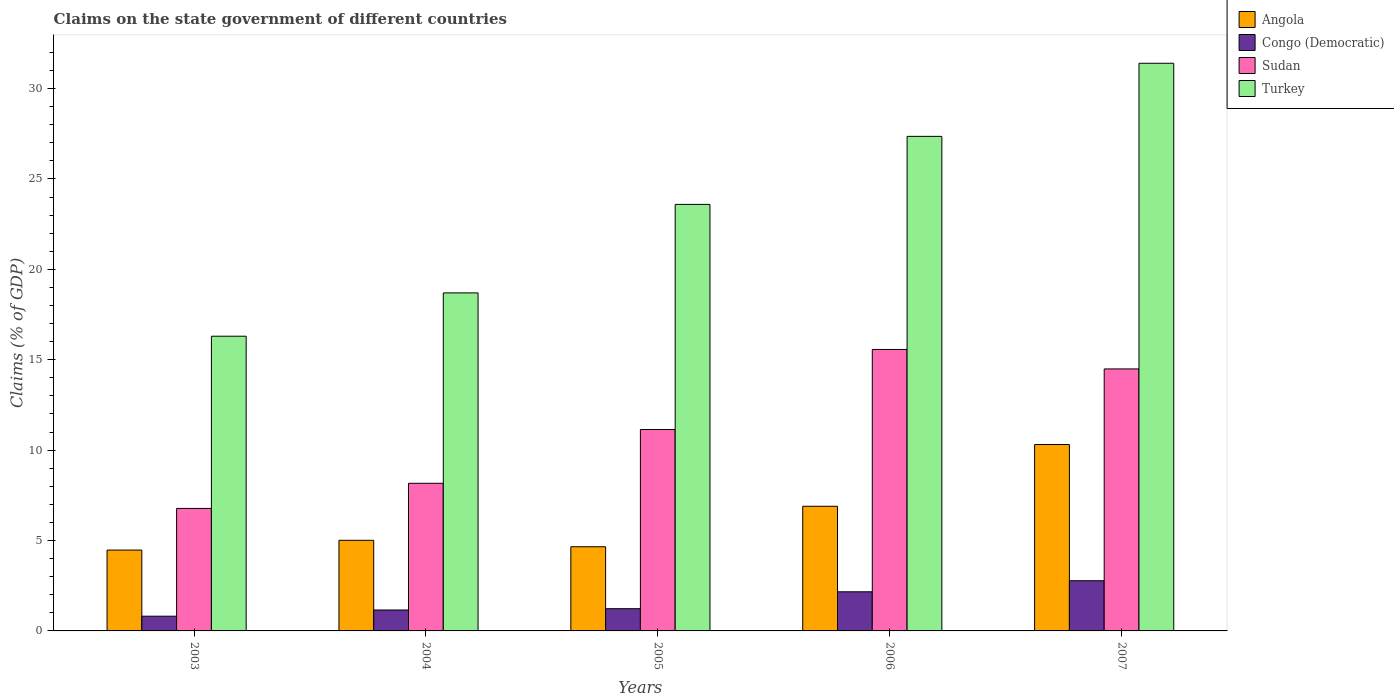How many different coloured bars are there?
Offer a very short reply. 4. How many groups of bars are there?
Your response must be concise. 5. Are the number of bars per tick equal to the number of legend labels?
Ensure brevity in your answer.  Yes. How many bars are there on the 3rd tick from the right?
Offer a very short reply. 4. What is the percentage of GDP claimed on the state government in Sudan in 2005?
Give a very brief answer. 11.14. Across all years, what is the maximum percentage of GDP claimed on the state government in Congo (Democratic)?
Your answer should be very brief. 2.78. Across all years, what is the minimum percentage of GDP claimed on the state government in Sudan?
Keep it short and to the point. 6.77. What is the total percentage of GDP claimed on the state government in Angola in the graph?
Your response must be concise. 31.34. What is the difference between the percentage of GDP claimed on the state government in Turkey in 2005 and that in 2006?
Keep it short and to the point. -3.76. What is the difference between the percentage of GDP claimed on the state government in Turkey in 2007 and the percentage of GDP claimed on the state government in Congo (Democratic) in 2004?
Your answer should be very brief. 30.24. What is the average percentage of GDP claimed on the state government in Turkey per year?
Your answer should be very brief. 23.47. In the year 2006, what is the difference between the percentage of GDP claimed on the state government in Turkey and percentage of GDP claimed on the state government in Congo (Democratic)?
Your answer should be compact. 25.19. In how many years, is the percentage of GDP claimed on the state government in Turkey greater than 24 %?
Ensure brevity in your answer.  2. What is the ratio of the percentage of GDP claimed on the state government in Sudan in 2004 to that in 2007?
Provide a short and direct response. 0.56. Is the difference between the percentage of GDP claimed on the state government in Turkey in 2004 and 2007 greater than the difference between the percentage of GDP claimed on the state government in Congo (Democratic) in 2004 and 2007?
Offer a very short reply. No. What is the difference between the highest and the second highest percentage of GDP claimed on the state government in Sudan?
Provide a short and direct response. 1.08. What is the difference between the highest and the lowest percentage of GDP claimed on the state government in Turkey?
Your answer should be very brief. 15.1. What does the 4th bar from the left in 2007 represents?
Your answer should be compact. Turkey. What does the 4th bar from the right in 2004 represents?
Keep it short and to the point. Angola. Is it the case that in every year, the sum of the percentage of GDP claimed on the state government in Congo (Democratic) and percentage of GDP claimed on the state government in Angola is greater than the percentage of GDP claimed on the state government in Turkey?
Give a very brief answer. No. Are all the bars in the graph horizontal?
Offer a very short reply. No. How many years are there in the graph?
Provide a succinct answer. 5. What is the difference between two consecutive major ticks on the Y-axis?
Provide a succinct answer. 5. Does the graph contain any zero values?
Ensure brevity in your answer.  No. Where does the legend appear in the graph?
Your response must be concise. Top right. How many legend labels are there?
Make the answer very short. 4. How are the legend labels stacked?
Provide a succinct answer. Vertical. What is the title of the graph?
Your answer should be very brief. Claims on the state government of different countries. Does "Swaziland" appear as one of the legend labels in the graph?
Make the answer very short. No. What is the label or title of the X-axis?
Your answer should be very brief. Years. What is the label or title of the Y-axis?
Offer a terse response. Claims (% of GDP). What is the Claims (% of GDP) in Angola in 2003?
Your answer should be very brief. 4.47. What is the Claims (% of GDP) of Congo (Democratic) in 2003?
Offer a very short reply. 0.81. What is the Claims (% of GDP) of Sudan in 2003?
Make the answer very short. 6.77. What is the Claims (% of GDP) in Turkey in 2003?
Offer a very short reply. 16.3. What is the Claims (% of GDP) in Angola in 2004?
Your answer should be compact. 5.01. What is the Claims (% of GDP) in Congo (Democratic) in 2004?
Ensure brevity in your answer.  1.16. What is the Claims (% of GDP) of Sudan in 2004?
Your answer should be very brief. 8.17. What is the Claims (% of GDP) in Turkey in 2004?
Your response must be concise. 18.7. What is the Claims (% of GDP) in Angola in 2005?
Your response must be concise. 4.66. What is the Claims (% of GDP) of Congo (Democratic) in 2005?
Ensure brevity in your answer.  1.23. What is the Claims (% of GDP) of Sudan in 2005?
Ensure brevity in your answer.  11.14. What is the Claims (% of GDP) in Turkey in 2005?
Offer a very short reply. 23.59. What is the Claims (% of GDP) in Angola in 2006?
Offer a very short reply. 6.89. What is the Claims (% of GDP) of Congo (Democratic) in 2006?
Offer a terse response. 2.16. What is the Claims (% of GDP) of Sudan in 2006?
Provide a short and direct response. 15.57. What is the Claims (% of GDP) of Turkey in 2006?
Make the answer very short. 27.35. What is the Claims (% of GDP) of Angola in 2007?
Your answer should be very brief. 10.31. What is the Claims (% of GDP) in Congo (Democratic) in 2007?
Offer a terse response. 2.78. What is the Claims (% of GDP) of Sudan in 2007?
Ensure brevity in your answer.  14.49. What is the Claims (% of GDP) in Turkey in 2007?
Keep it short and to the point. 31.4. Across all years, what is the maximum Claims (% of GDP) in Angola?
Provide a short and direct response. 10.31. Across all years, what is the maximum Claims (% of GDP) in Congo (Democratic)?
Provide a succinct answer. 2.78. Across all years, what is the maximum Claims (% of GDP) of Sudan?
Offer a terse response. 15.57. Across all years, what is the maximum Claims (% of GDP) of Turkey?
Offer a terse response. 31.4. Across all years, what is the minimum Claims (% of GDP) of Angola?
Ensure brevity in your answer.  4.47. Across all years, what is the minimum Claims (% of GDP) of Congo (Democratic)?
Ensure brevity in your answer.  0.81. Across all years, what is the minimum Claims (% of GDP) of Sudan?
Your answer should be compact. 6.77. Across all years, what is the minimum Claims (% of GDP) of Turkey?
Provide a succinct answer. 16.3. What is the total Claims (% of GDP) of Angola in the graph?
Your answer should be compact. 31.34. What is the total Claims (% of GDP) of Congo (Democratic) in the graph?
Provide a succinct answer. 8.14. What is the total Claims (% of GDP) of Sudan in the graph?
Offer a terse response. 56.14. What is the total Claims (% of GDP) of Turkey in the graph?
Keep it short and to the point. 117.34. What is the difference between the Claims (% of GDP) of Angola in 2003 and that in 2004?
Provide a short and direct response. -0.54. What is the difference between the Claims (% of GDP) in Congo (Democratic) in 2003 and that in 2004?
Your answer should be very brief. -0.34. What is the difference between the Claims (% of GDP) in Sudan in 2003 and that in 2004?
Make the answer very short. -1.39. What is the difference between the Claims (% of GDP) in Turkey in 2003 and that in 2004?
Make the answer very short. -2.4. What is the difference between the Claims (% of GDP) of Angola in 2003 and that in 2005?
Give a very brief answer. -0.18. What is the difference between the Claims (% of GDP) of Congo (Democratic) in 2003 and that in 2005?
Your answer should be compact. -0.41. What is the difference between the Claims (% of GDP) of Sudan in 2003 and that in 2005?
Offer a terse response. -4.36. What is the difference between the Claims (% of GDP) of Turkey in 2003 and that in 2005?
Give a very brief answer. -7.29. What is the difference between the Claims (% of GDP) in Angola in 2003 and that in 2006?
Provide a short and direct response. -2.42. What is the difference between the Claims (% of GDP) in Congo (Democratic) in 2003 and that in 2006?
Make the answer very short. -1.35. What is the difference between the Claims (% of GDP) of Sudan in 2003 and that in 2006?
Keep it short and to the point. -8.79. What is the difference between the Claims (% of GDP) of Turkey in 2003 and that in 2006?
Your answer should be compact. -11.05. What is the difference between the Claims (% of GDP) of Angola in 2003 and that in 2007?
Provide a succinct answer. -5.84. What is the difference between the Claims (% of GDP) in Congo (Democratic) in 2003 and that in 2007?
Provide a succinct answer. -1.96. What is the difference between the Claims (% of GDP) of Sudan in 2003 and that in 2007?
Offer a terse response. -7.72. What is the difference between the Claims (% of GDP) in Turkey in 2003 and that in 2007?
Ensure brevity in your answer.  -15.1. What is the difference between the Claims (% of GDP) of Angola in 2004 and that in 2005?
Offer a very short reply. 0.36. What is the difference between the Claims (% of GDP) of Congo (Democratic) in 2004 and that in 2005?
Your response must be concise. -0.07. What is the difference between the Claims (% of GDP) in Sudan in 2004 and that in 2005?
Give a very brief answer. -2.97. What is the difference between the Claims (% of GDP) of Turkey in 2004 and that in 2005?
Offer a terse response. -4.89. What is the difference between the Claims (% of GDP) in Angola in 2004 and that in 2006?
Give a very brief answer. -1.88. What is the difference between the Claims (% of GDP) of Congo (Democratic) in 2004 and that in 2006?
Your answer should be compact. -1.01. What is the difference between the Claims (% of GDP) in Sudan in 2004 and that in 2006?
Provide a succinct answer. -7.4. What is the difference between the Claims (% of GDP) in Turkey in 2004 and that in 2006?
Make the answer very short. -8.66. What is the difference between the Claims (% of GDP) of Angola in 2004 and that in 2007?
Make the answer very short. -5.3. What is the difference between the Claims (% of GDP) in Congo (Democratic) in 2004 and that in 2007?
Your answer should be very brief. -1.62. What is the difference between the Claims (% of GDP) of Sudan in 2004 and that in 2007?
Your response must be concise. -6.33. What is the difference between the Claims (% of GDP) in Turkey in 2004 and that in 2007?
Your answer should be very brief. -12.7. What is the difference between the Claims (% of GDP) in Angola in 2005 and that in 2006?
Provide a short and direct response. -2.24. What is the difference between the Claims (% of GDP) of Congo (Democratic) in 2005 and that in 2006?
Give a very brief answer. -0.94. What is the difference between the Claims (% of GDP) of Sudan in 2005 and that in 2006?
Your response must be concise. -4.43. What is the difference between the Claims (% of GDP) of Turkey in 2005 and that in 2006?
Offer a very short reply. -3.76. What is the difference between the Claims (% of GDP) of Angola in 2005 and that in 2007?
Keep it short and to the point. -5.65. What is the difference between the Claims (% of GDP) in Congo (Democratic) in 2005 and that in 2007?
Make the answer very short. -1.55. What is the difference between the Claims (% of GDP) in Sudan in 2005 and that in 2007?
Ensure brevity in your answer.  -3.35. What is the difference between the Claims (% of GDP) of Turkey in 2005 and that in 2007?
Make the answer very short. -7.81. What is the difference between the Claims (% of GDP) of Angola in 2006 and that in 2007?
Give a very brief answer. -3.42. What is the difference between the Claims (% of GDP) of Congo (Democratic) in 2006 and that in 2007?
Offer a very short reply. -0.61. What is the difference between the Claims (% of GDP) of Sudan in 2006 and that in 2007?
Your answer should be compact. 1.08. What is the difference between the Claims (% of GDP) in Turkey in 2006 and that in 2007?
Keep it short and to the point. -4.04. What is the difference between the Claims (% of GDP) in Angola in 2003 and the Claims (% of GDP) in Congo (Democratic) in 2004?
Make the answer very short. 3.31. What is the difference between the Claims (% of GDP) in Angola in 2003 and the Claims (% of GDP) in Sudan in 2004?
Ensure brevity in your answer.  -3.69. What is the difference between the Claims (% of GDP) of Angola in 2003 and the Claims (% of GDP) of Turkey in 2004?
Make the answer very short. -14.22. What is the difference between the Claims (% of GDP) in Congo (Democratic) in 2003 and the Claims (% of GDP) in Sudan in 2004?
Provide a succinct answer. -7.35. What is the difference between the Claims (% of GDP) in Congo (Democratic) in 2003 and the Claims (% of GDP) in Turkey in 2004?
Your answer should be very brief. -17.88. What is the difference between the Claims (% of GDP) in Sudan in 2003 and the Claims (% of GDP) in Turkey in 2004?
Offer a terse response. -11.92. What is the difference between the Claims (% of GDP) of Angola in 2003 and the Claims (% of GDP) of Congo (Democratic) in 2005?
Your response must be concise. 3.24. What is the difference between the Claims (% of GDP) of Angola in 2003 and the Claims (% of GDP) of Sudan in 2005?
Provide a succinct answer. -6.67. What is the difference between the Claims (% of GDP) of Angola in 2003 and the Claims (% of GDP) of Turkey in 2005?
Give a very brief answer. -19.12. What is the difference between the Claims (% of GDP) in Congo (Democratic) in 2003 and the Claims (% of GDP) in Sudan in 2005?
Give a very brief answer. -10.32. What is the difference between the Claims (% of GDP) of Congo (Democratic) in 2003 and the Claims (% of GDP) of Turkey in 2005?
Your answer should be compact. -22.78. What is the difference between the Claims (% of GDP) of Sudan in 2003 and the Claims (% of GDP) of Turkey in 2005?
Ensure brevity in your answer.  -16.82. What is the difference between the Claims (% of GDP) in Angola in 2003 and the Claims (% of GDP) in Congo (Democratic) in 2006?
Make the answer very short. 2.31. What is the difference between the Claims (% of GDP) in Angola in 2003 and the Claims (% of GDP) in Sudan in 2006?
Your answer should be very brief. -11.1. What is the difference between the Claims (% of GDP) in Angola in 2003 and the Claims (% of GDP) in Turkey in 2006?
Provide a succinct answer. -22.88. What is the difference between the Claims (% of GDP) in Congo (Democratic) in 2003 and the Claims (% of GDP) in Sudan in 2006?
Provide a short and direct response. -14.75. What is the difference between the Claims (% of GDP) of Congo (Democratic) in 2003 and the Claims (% of GDP) of Turkey in 2006?
Your answer should be very brief. -26.54. What is the difference between the Claims (% of GDP) in Sudan in 2003 and the Claims (% of GDP) in Turkey in 2006?
Your response must be concise. -20.58. What is the difference between the Claims (% of GDP) in Angola in 2003 and the Claims (% of GDP) in Congo (Democratic) in 2007?
Provide a succinct answer. 1.7. What is the difference between the Claims (% of GDP) in Angola in 2003 and the Claims (% of GDP) in Sudan in 2007?
Keep it short and to the point. -10.02. What is the difference between the Claims (% of GDP) in Angola in 2003 and the Claims (% of GDP) in Turkey in 2007?
Provide a short and direct response. -26.93. What is the difference between the Claims (% of GDP) in Congo (Democratic) in 2003 and the Claims (% of GDP) in Sudan in 2007?
Your response must be concise. -13.68. What is the difference between the Claims (% of GDP) of Congo (Democratic) in 2003 and the Claims (% of GDP) of Turkey in 2007?
Offer a terse response. -30.58. What is the difference between the Claims (% of GDP) in Sudan in 2003 and the Claims (% of GDP) in Turkey in 2007?
Give a very brief answer. -24.62. What is the difference between the Claims (% of GDP) in Angola in 2004 and the Claims (% of GDP) in Congo (Democratic) in 2005?
Make the answer very short. 3.78. What is the difference between the Claims (% of GDP) of Angola in 2004 and the Claims (% of GDP) of Sudan in 2005?
Give a very brief answer. -6.13. What is the difference between the Claims (% of GDP) in Angola in 2004 and the Claims (% of GDP) in Turkey in 2005?
Offer a very short reply. -18.58. What is the difference between the Claims (% of GDP) in Congo (Democratic) in 2004 and the Claims (% of GDP) in Sudan in 2005?
Keep it short and to the point. -9.98. What is the difference between the Claims (% of GDP) of Congo (Democratic) in 2004 and the Claims (% of GDP) of Turkey in 2005?
Offer a terse response. -22.43. What is the difference between the Claims (% of GDP) of Sudan in 2004 and the Claims (% of GDP) of Turkey in 2005?
Offer a very short reply. -15.43. What is the difference between the Claims (% of GDP) of Angola in 2004 and the Claims (% of GDP) of Congo (Democratic) in 2006?
Ensure brevity in your answer.  2.85. What is the difference between the Claims (% of GDP) of Angola in 2004 and the Claims (% of GDP) of Sudan in 2006?
Give a very brief answer. -10.56. What is the difference between the Claims (% of GDP) of Angola in 2004 and the Claims (% of GDP) of Turkey in 2006?
Provide a succinct answer. -22.34. What is the difference between the Claims (% of GDP) in Congo (Democratic) in 2004 and the Claims (% of GDP) in Sudan in 2006?
Give a very brief answer. -14.41. What is the difference between the Claims (% of GDP) of Congo (Democratic) in 2004 and the Claims (% of GDP) of Turkey in 2006?
Make the answer very short. -26.2. What is the difference between the Claims (% of GDP) in Sudan in 2004 and the Claims (% of GDP) in Turkey in 2006?
Your answer should be very brief. -19.19. What is the difference between the Claims (% of GDP) of Angola in 2004 and the Claims (% of GDP) of Congo (Democratic) in 2007?
Offer a terse response. 2.24. What is the difference between the Claims (% of GDP) of Angola in 2004 and the Claims (% of GDP) of Sudan in 2007?
Give a very brief answer. -9.48. What is the difference between the Claims (% of GDP) in Angola in 2004 and the Claims (% of GDP) in Turkey in 2007?
Make the answer very short. -26.39. What is the difference between the Claims (% of GDP) of Congo (Democratic) in 2004 and the Claims (% of GDP) of Sudan in 2007?
Provide a short and direct response. -13.33. What is the difference between the Claims (% of GDP) of Congo (Democratic) in 2004 and the Claims (% of GDP) of Turkey in 2007?
Provide a short and direct response. -30.24. What is the difference between the Claims (% of GDP) in Sudan in 2004 and the Claims (% of GDP) in Turkey in 2007?
Your response must be concise. -23.23. What is the difference between the Claims (% of GDP) in Angola in 2005 and the Claims (% of GDP) in Congo (Democratic) in 2006?
Your answer should be compact. 2.49. What is the difference between the Claims (% of GDP) of Angola in 2005 and the Claims (% of GDP) of Sudan in 2006?
Your answer should be very brief. -10.91. What is the difference between the Claims (% of GDP) in Angola in 2005 and the Claims (% of GDP) in Turkey in 2006?
Give a very brief answer. -22.7. What is the difference between the Claims (% of GDP) in Congo (Democratic) in 2005 and the Claims (% of GDP) in Sudan in 2006?
Your answer should be compact. -14.34. What is the difference between the Claims (% of GDP) of Congo (Democratic) in 2005 and the Claims (% of GDP) of Turkey in 2006?
Your response must be concise. -26.12. What is the difference between the Claims (% of GDP) of Sudan in 2005 and the Claims (% of GDP) of Turkey in 2006?
Provide a short and direct response. -16.21. What is the difference between the Claims (% of GDP) of Angola in 2005 and the Claims (% of GDP) of Congo (Democratic) in 2007?
Offer a very short reply. 1.88. What is the difference between the Claims (% of GDP) of Angola in 2005 and the Claims (% of GDP) of Sudan in 2007?
Keep it short and to the point. -9.84. What is the difference between the Claims (% of GDP) of Angola in 2005 and the Claims (% of GDP) of Turkey in 2007?
Your response must be concise. -26.74. What is the difference between the Claims (% of GDP) in Congo (Democratic) in 2005 and the Claims (% of GDP) in Sudan in 2007?
Make the answer very short. -13.26. What is the difference between the Claims (% of GDP) in Congo (Democratic) in 2005 and the Claims (% of GDP) in Turkey in 2007?
Provide a succinct answer. -30.17. What is the difference between the Claims (% of GDP) of Sudan in 2005 and the Claims (% of GDP) of Turkey in 2007?
Offer a very short reply. -20.26. What is the difference between the Claims (% of GDP) of Angola in 2006 and the Claims (% of GDP) of Congo (Democratic) in 2007?
Ensure brevity in your answer.  4.12. What is the difference between the Claims (% of GDP) in Angola in 2006 and the Claims (% of GDP) in Sudan in 2007?
Offer a terse response. -7.6. What is the difference between the Claims (% of GDP) in Angola in 2006 and the Claims (% of GDP) in Turkey in 2007?
Your response must be concise. -24.5. What is the difference between the Claims (% of GDP) in Congo (Democratic) in 2006 and the Claims (% of GDP) in Sudan in 2007?
Offer a very short reply. -12.33. What is the difference between the Claims (% of GDP) of Congo (Democratic) in 2006 and the Claims (% of GDP) of Turkey in 2007?
Offer a terse response. -29.23. What is the difference between the Claims (% of GDP) of Sudan in 2006 and the Claims (% of GDP) of Turkey in 2007?
Keep it short and to the point. -15.83. What is the average Claims (% of GDP) of Angola per year?
Your answer should be compact. 6.27. What is the average Claims (% of GDP) in Congo (Democratic) per year?
Give a very brief answer. 1.63. What is the average Claims (% of GDP) in Sudan per year?
Offer a terse response. 11.23. What is the average Claims (% of GDP) of Turkey per year?
Make the answer very short. 23.47. In the year 2003, what is the difference between the Claims (% of GDP) in Angola and Claims (% of GDP) in Congo (Democratic)?
Offer a terse response. 3.66. In the year 2003, what is the difference between the Claims (% of GDP) of Angola and Claims (% of GDP) of Sudan?
Your response must be concise. -2.3. In the year 2003, what is the difference between the Claims (% of GDP) in Angola and Claims (% of GDP) in Turkey?
Your answer should be very brief. -11.83. In the year 2003, what is the difference between the Claims (% of GDP) in Congo (Democratic) and Claims (% of GDP) in Sudan?
Give a very brief answer. -5.96. In the year 2003, what is the difference between the Claims (% of GDP) of Congo (Democratic) and Claims (% of GDP) of Turkey?
Ensure brevity in your answer.  -15.49. In the year 2003, what is the difference between the Claims (% of GDP) in Sudan and Claims (% of GDP) in Turkey?
Offer a terse response. -9.53. In the year 2004, what is the difference between the Claims (% of GDP) of Angola and Claims (% of GDP) of Congo (Democratic)?
Offer a terse response. 3.86. In the year 2004, what is the difference between the Claims (% of GDP) in Angola and Claims (% of GDP) in Sudan?
Offer a very short reply. -3.15. In the year 2004, what is the difference between the Claims (% of GDP) of Angola and Claims (% of GDP) of Turkey?
Offer a terse response. -13.68. In the year 2004, what is the difference between the Claims (% of GDP) in Congo (Democratic) and Claims (% of GDP) in Sudan?
Provide a short and direct response. -7.01. In the year 2004, what is the difference between the Claims (% of GDP) in Congo (Democratic) and Claims (% of GDP) in Turkey?
Offer a very short reply. -17.54. In the year 2004, what is the difference between the Claims (% of GDP) of Sudan and Claims (% of GDP) of Turkey?
Provide a short and direct response. -10.53. In the year 2005, what is the difference between the Claims (% of GDP) of Angola and Claims (% of GDP) of Congo (Democratic)?
Your answer should be very brief. 3.43. In the year 2005, what is the difference between the Claims (% of GDP) in Angola and Claims (% of GDP) in Sudan?
Your answer should be very brief. -6.48. In the year 2005, what is the difference between the Claims (% of GDP) of Angola and Claims (% of GDP) of Turkey?
Give a very brief answer. -18.94. In the year 2005, what is the difference between the Claims (% of GDP) in Congo (Democratic) and Claims (% of GDP) in Sudan?
Offer a very short reply. -9.91. In the year 2005, what is the difference between the Claims (% of GDP) in Congo (Democratic) and Claims (% of GDP) in Turkey?
Offer a terse response. -22.36. In the year 2005, what is the difference between the Claims (% of GDP) of Sudan and Claims (% of GDP) of Turkey?
Give a very brief answer. -12.45. In the year 2006, what is the difference between the Claims (% of GDP) in Angola and Claims (% of GDP) in Congo (Democratic)?
Your response must be concise. 4.73. In the year 2006, what is the difference between the Claims (% of GDP) in Angola and Claims (% of GDP) in Sudan?
Provide a short and direct response. -8.67. In the year 2006, what is the difference between the Claims (% of GDP) in Angola and Claims (% of GDP) in Turkey?
Your answer should be very brief. -20.46. In the year 2006, what is the difference between the Claims (% of GDP) of Congo (Democratic) and Claims (% of GDP) of Sudan?
Give a very brief answer. -13.4. In the year 2006, what is the difference between the Claims (% of GDP) in Congo (Democratic) and Claims (% of GDP) in Turkey?
Your answer should be very brief. -25.19. In the year 2006, what is the difference between the Claims (% of GDP) of Sudan and Claims (% of GDP) of Turkey?
Your response must be concise. -11.79. In the year 2007, what is the difference between the Claims (% of GDP) in Angola and Claims (% of GDP) in Congo (Democratic)?
Offer a terse response. 7.53. In the year 2007, what is the difference between the Claims (% of GDP) in Angola and Claims (% of GDP) in Sudan?
Offer a very short reply. -4.18. In the year 2007, what is the difference between the Claims (% of GDP) in Angola and Claims (% of GDP) in Turkey?
Make the answer very short. -21.09. In the year 2007, what is the difference between the Claims (% of GDP) of Congo (Democratic) and Claims (% of GDP) of Sudan?
Your answer should be compact. -11.71. In the year 2007, what is the difference between the Claims (% of GDP) of Congo (Democratic) and Claims (% of GDP) of Turkey?
Offer a terse response. -28.62. In the year 2007, what is the difference between the Claims (% of GDP) of Sudan and Claims (% of GDP) of Turkey?
Give a very brief answer. -16.91. What is the ratio of the Claims (% of GDP) in Angola in 2003 to that in 2004?
Offer a terse response. 0.89. What is the ratio of the Claims (% of GDP) in Congo (Democratic) in 2003 to that in 2004?
Your response must be concise. 0.7. What is the ratio of the Claims (% of GDP) of Sudan in 2003 to that in 2004?
Provide a succinct answer. 0.83. What is the ratio of the Claims (% of GDP) in Turkey in 2003 to that in 2004?
Your answer should be very brief. 0.87. What is the ratio of the Claims (% of GDP) of Angola in 2003 to that in 2005?
Your answer should be very brief. 0.96. What is the ratio of the Claims (% of GDP) in Congo (Democratic) in 2003 to that in 2005?
Ensure brevity in your answer.  0.66. What is the ratio of the Claims (% of GDP) of Sudan in 2003 to that in 2005?
Keep it short and to the point. 0.61. What is the ratio of the Claims (% of GDP) in Turkey in 2003 to that in 2005?
Offer a terse response. 0.69. What is the ratio of the Claims (% of GDP) of Angola in 2003 to that in 2006?
Give a very brief answer. 0.65. What is the ratio of the Claims (% of GDP) in Congo (Democratic) in 2003 to that in 2006?
Give a very brief answer. 0.38. What is the ratio of the Claims (% of GDP) of Sudan in 2003 to that in 2006?
Give a very brief answer. 0.44. What is the ratio of the Claims (% of GDP) in Turkey in 2003 to that in 2006?
Provide a short and direct response. 0.6. What is the ratio of the Claims (% of GDP) of Angola in 2003 to that in 2007?
Your answer should be very brief. 0.43. What is the ratio of the Claims (% of GDP) of Congo (Democratic) in 2003 to that in 2007?
Keep it short and to the point. 0.29. What is the ratio of the Claims (% of GDP) in Sudan in 2003 to that in 2007?
Your answer should be very brief. 0.47. What is the ratio of the Claims (% of GDP) of Turkey in 2003 to that in 2007?
Your response must be concise. 0.52. What is the ratio of the Claims (% of GDP) of Angola in 2004 to that in 2005?
Give a very brief answer. 1.08. What is the ratio of the Claims (% of GDP) of Congo (Democratic) in 2004 to that in 2005?
Ensure brevity in your answer.  0.94. What is the ratio of the Claims (% of GDP) of Sudan in 2004 to that in 2005?
Provide a succinct answer. 0.73. What is the ratio of the Claims (% of GDP) of Turkey in 2004 to that in 2005?
Offer a terse response. 0.79. What is the ratio of the Claims (% of GDP) in Angola in 2004 to that in 2006?
Offer a very short reply. 0.73. What is the ratio of the Claims (% of GDP) of Congo (Democratic) in 2004 to that in 2006?
Make the answer very short. 0.53. What is the ratio of the Claims (% of GDP) in Sudan in 2004 to that in 2006?
Provide a succinct answer. 0.52. What is the ratio of the Claims (% of GDP) in Turkey in 2004 to that in 2006?
Keep it short and to the point. 0.68. What is the ratio of the Claims (% of GDP) of Angola in 2004 to that in 2007?
Keep it short and to the point. 0.49. What is the ratio of the Claims (% of GDP) of Congo (Democratic) in 2004 to that in 2007?
Provide a short and direct response. 0.42. What is the ratio of the Claims (% of GDP) of Sudan in 2004 to that in 2007?
Ensure brevity in your answer.  0.56. What is the ratio of the Claims (% of GDP) of Turkey in 2004 to that in 2007?
Provide a succinct answer. 0.6. What is the ratio of the Claims (% of GDP) of Angola in 2005 to that in 2006?
Ensure brevity in your answer.  0.68. What is the ratio of the Claims (% of GDP) of Congo (Democratic) in 2005 to that in 2006?
Your response must be concise. 0.57. What is the ratio of the Claims (% of GDP) in Sudan in 2005 to that in 2006?
Ensure brevity in your answer.  0.72. What is the ratio of the Claims (% of GDP) of Turkey in 2005 to that in 2006?
Ensure brevity in your answer.  0.86. What is the ratio of the Claims (% of GDP) of Angola in 2005 to that in 2007?
Your response must be concise. 0.45. What is the ratio of the Claims (% of GDP) of Congo (Democratic) in 2005 to that in 2007?
Provide a short and direct response. 0.44. What is the ratio of the Claims (% of GDP) in Sudan in 2005 to that in 2007?
Provide a short and direct response. 0.77. What is the ratio of the Claims (% of GDP) in Turkey in 2005 to that in 2007?
Give a very brief answer. 0.75. What is the ratio of the Claims (% of GDP) of Angola in 2006 to that in 2007?
Ensure brevity in your answer.  0.67. What is the ratio of the Claims (% of GDP) in Congo (Democratic) in 2006 to that in 2007?
Your response must be concise. 0.78. What is the ratio of the Claims (% of GDP) in Sudan in 2006 to that in 2007?
Your answer should be very brief. 1.07. What is the ratio of the Claims (% of GDP) in Turkey in 2006 to that in 2007?
Offer a very short reply. 0.87. What is the difference between the highest and the second highest Claims (% of GDP) in Angola?
Your answer should be compact. 3.42. What is the difference between the highest and the second highest Claims (% of GDP) of Congo (Democratic)?
Give a very brief answer. 0.61. What is the difference between the highest and the second highest Claims (% of GDP) of Sudan?
Keep it short and to the point. 1.08. What is the difference between the highest and the second highest Claims (% of GDP) in Turkey?
Provide a succinct answer. 4.04. What is the difference between the highest and the lowest Claims (% of GDP) in Angola?
Provide a short and direct response. 5.84. What is the difference between the highest and the lowest Claims (% of GDP) in Congo (Democratic)?
Give a very brief answer. 1.96. What is the difference between the highest and the lowest Claims (% of GDP) of Sudan?
Make the answer very short. 8.79. What is the difference between the highest and the lowest Claims (% of GDP) of Turkey?
Offer a very short reply. 15.1. 